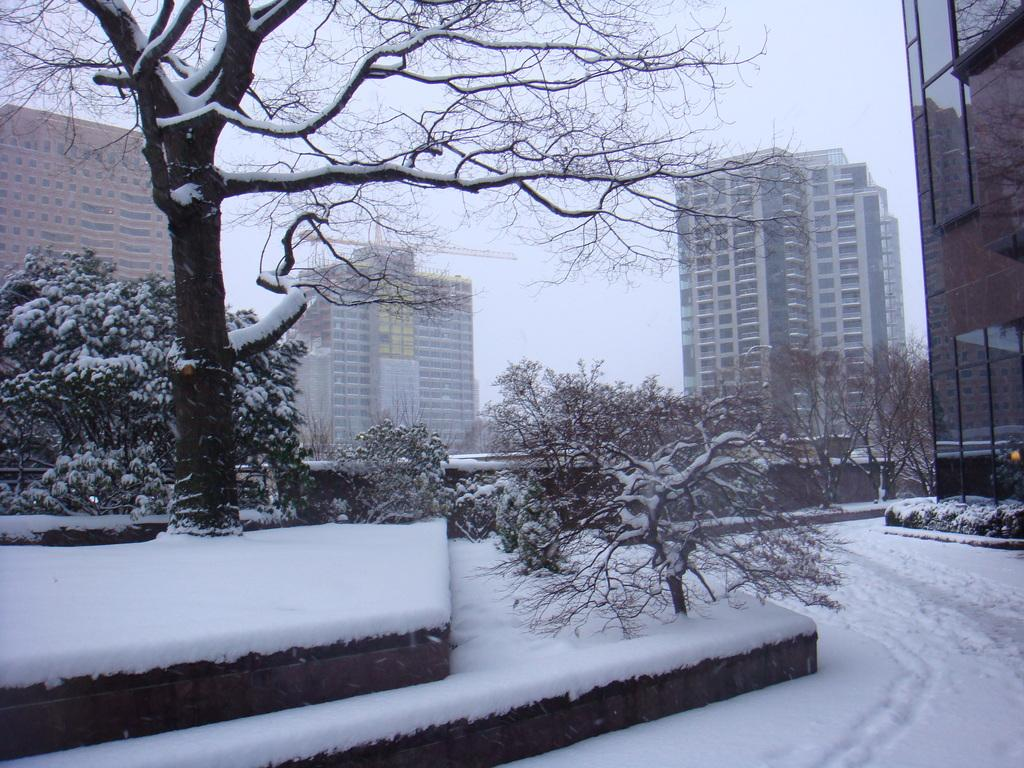What is the condition of the ground in the image? The ground is covered with snow. Where are the trees located in the image? The trees are in the left corner of the image, and they are covered with snow. What can be seen in the background of the image? There are buildings in the background of the image. How many roofs can be seen on the church in the image? There is no church present in the image, so it is not possible to determine the number of roofs. 